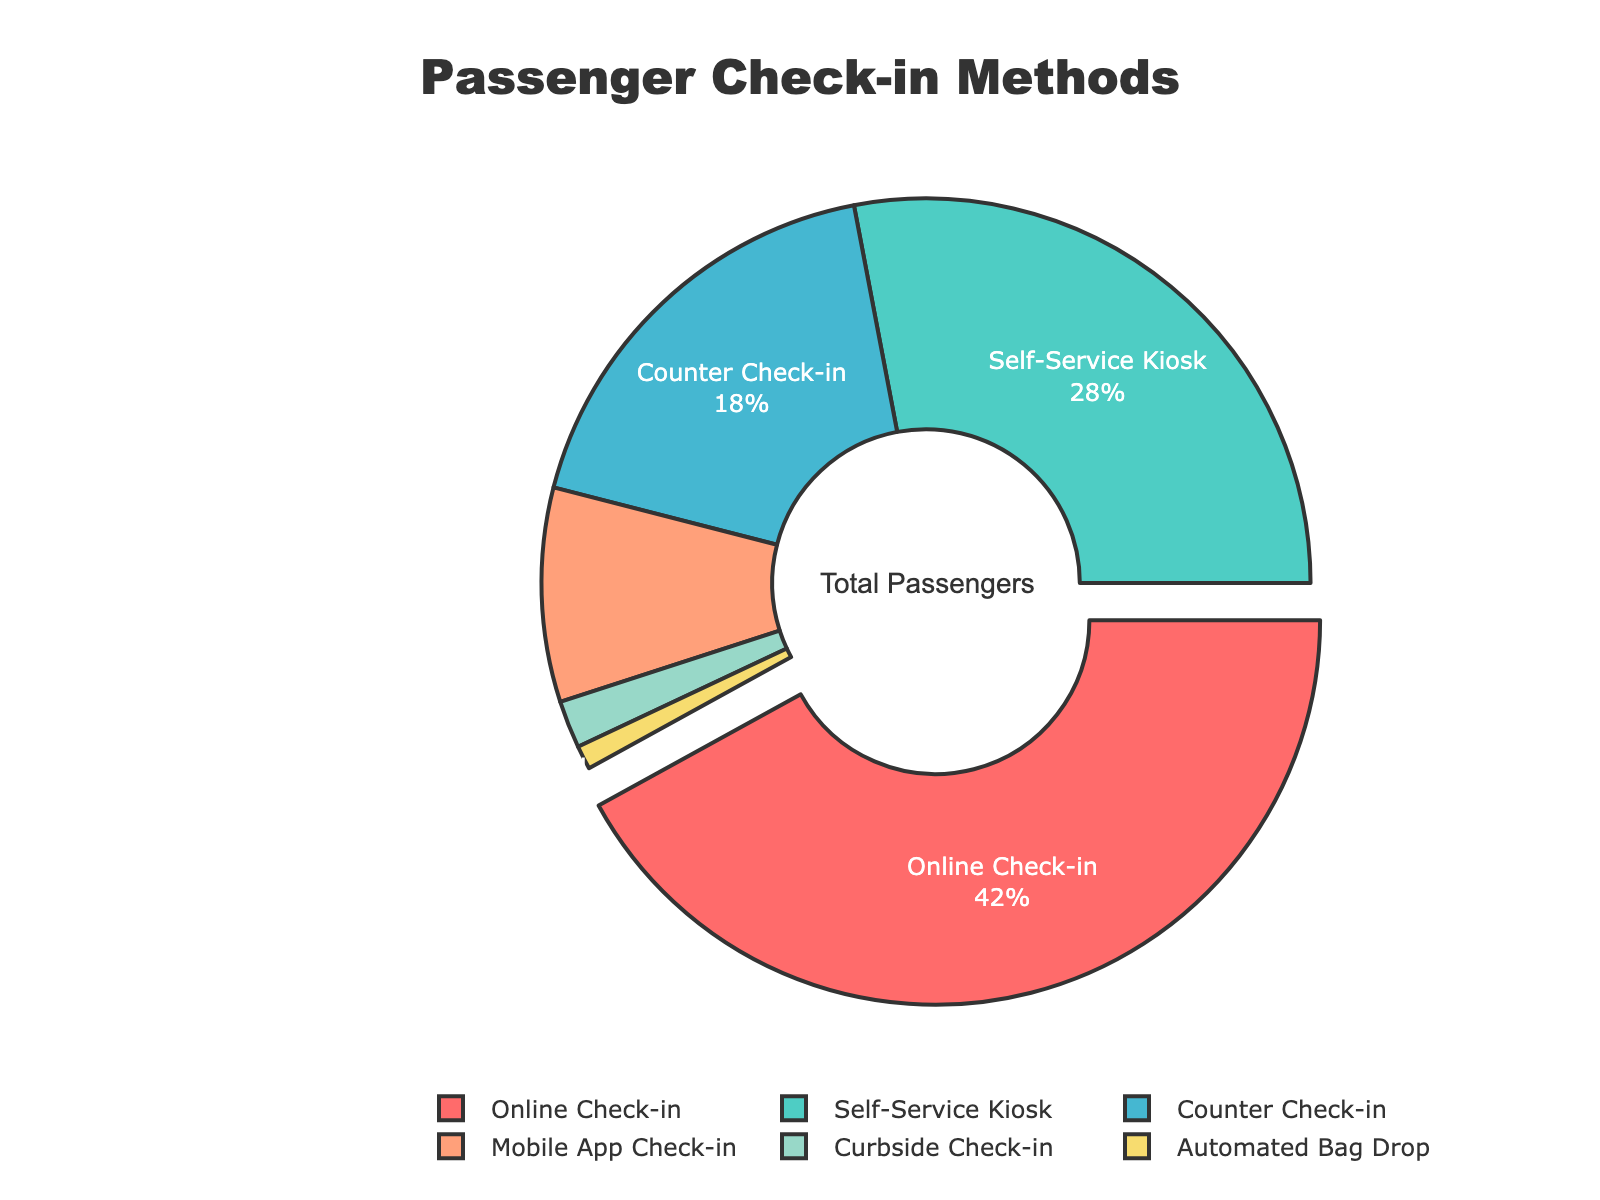Which check-in method is used by the highest percentage of passengers? The colored segments of the pie chart with percentages indicate the method used by passengers. The largest segment represents "Online Check-in" with 42%.
Answer: Online Check-in How much more popular is the most used check-in method compared to the least used method? The most used method is "Online Check-in" with 42%, and the least used is "Automated Bag Drop" with 1%. The difference is calculated by subtracting the smallest percentage from the largest: 42% - 1% = 41%.
Answer: 41% What percentage of passengers use either the "Self-Service Kiosk" or "Counter Check-in"? Add the percentages for "Self-Service Kiosk" (28%) and "Counter Check-in" (18%): 28% + 18% = 46%.
Answer: 46% Which two check-in methods combined make up less than 5% of check-ins? By observing the segments, "Curbside Check-in" (2%) and "Automated Bag Drop" (1%) are both small and sum up to 2% + 1% = 3%, which is less than 5%.
Answer: Curbside Check-in and Automated Bag Drop Which check-in method is represented by the smallest slice, and what is its percentage? The smallest slice on the pie chart represents "Automated Bag Drop" with a percentage of 1%.
Answer: Automated Bag Drop, 1% Is "Mobile App Check-in" more popular than "Curbside Check-in"? Compare the respective percentages of the two methods: "Mobile App Check-in" has 9%, while "Curbside Check-in" has 2%. Therefore, "Mobile App Check-in" is more popular.
Answer: Yes What is the total percentage of passengers that do not use online check-in? Subtract the percentage of "Online Check-in" from 100%: 100% - 42% = 58%.
Answer: 58% Arrange the check-in methods in descending order of usage percentage. Start with the highest percentage and move to the lowest: Online Check-in (42%), Self-Service Kiosk (28%), Counter Check-in (18%), Mobile App Check-in (9%), Curbside Check-in (2%), Automated Bag Drop (1%).
Answer: Online Check-in, Self-Service Kiosk, Counter Check-in, Mobile App Check-in, Curbside Check-in, Automated Bag Drop 